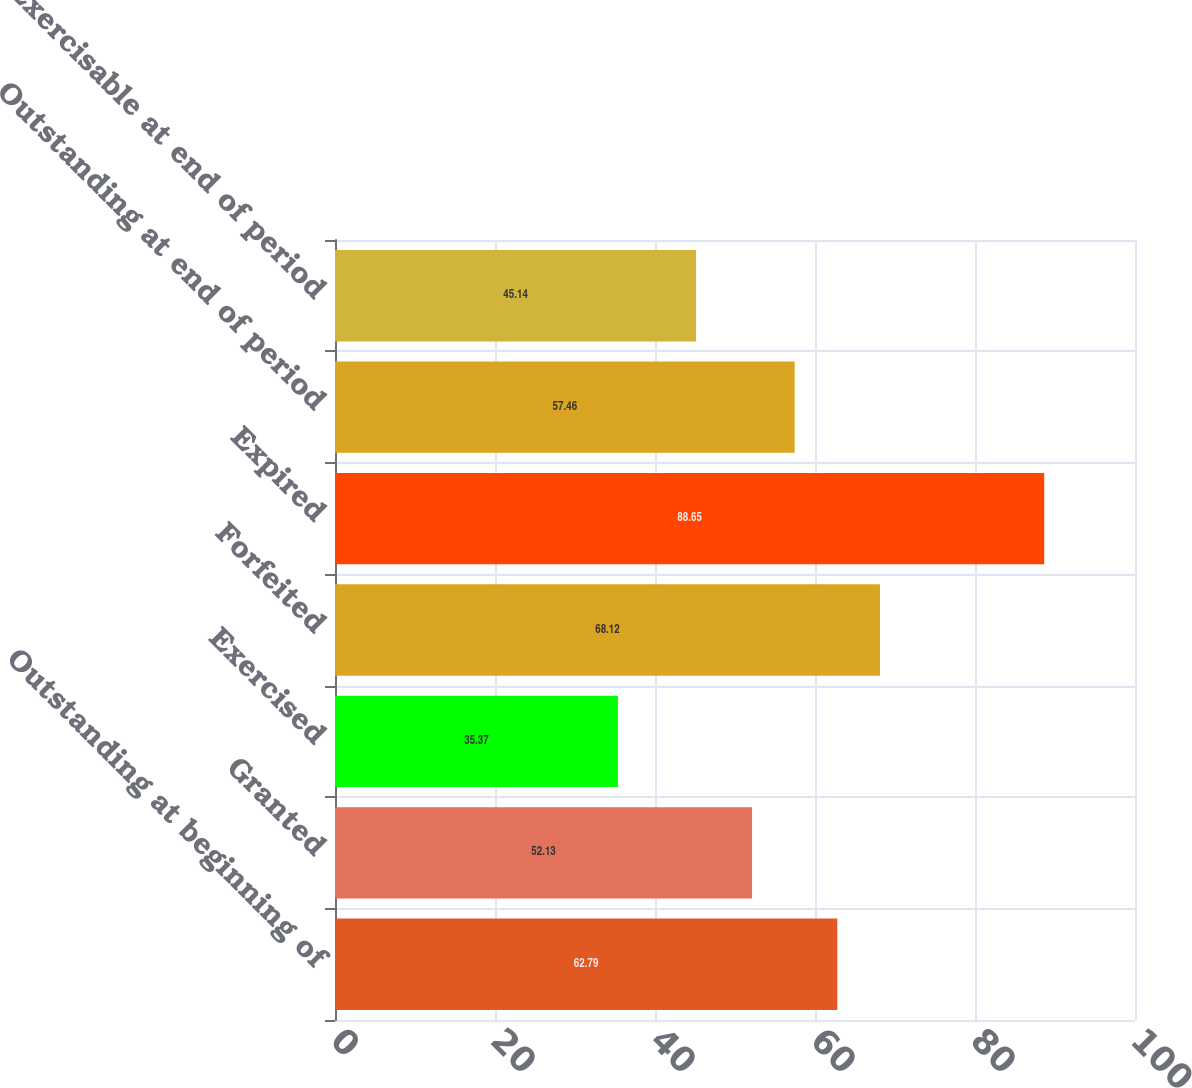Convert chart. <chart><loc_0><loc_0><loc_500><loc_500><bar_chart><fcel>Outstanding at beginning of<fcel>Granted<fcel>Exercised<fcel>Forfeited<fcel>Expired<fcel>Outstanding at end of period<fcel>Exercisable at end of period<nl><fcel>62.79<fcel>52.13<fcel>35.37<fcel>68.12<fcel>88.65<fcel>57.46<fcel>45.14<nl></chart> 